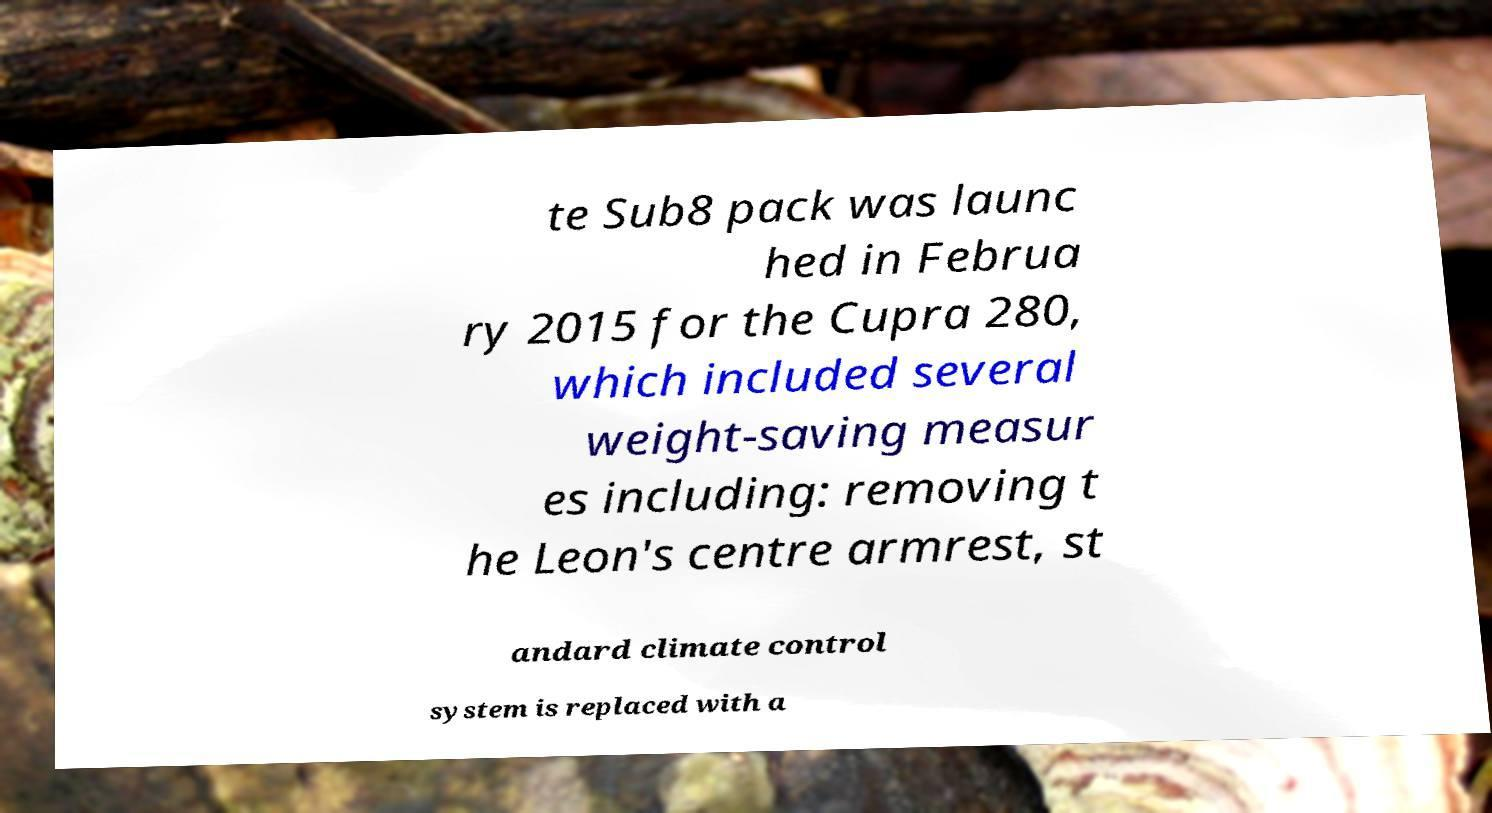For documentation purposes, I need the text within this image transcribed. Could you provide that? te Sub8 pack was launc hed in Februa ry 2015 for the Cupra 280, which included several weight-saving measur es including: removing t he Leon's centre armrest, st andard climate control system is replaced with a 